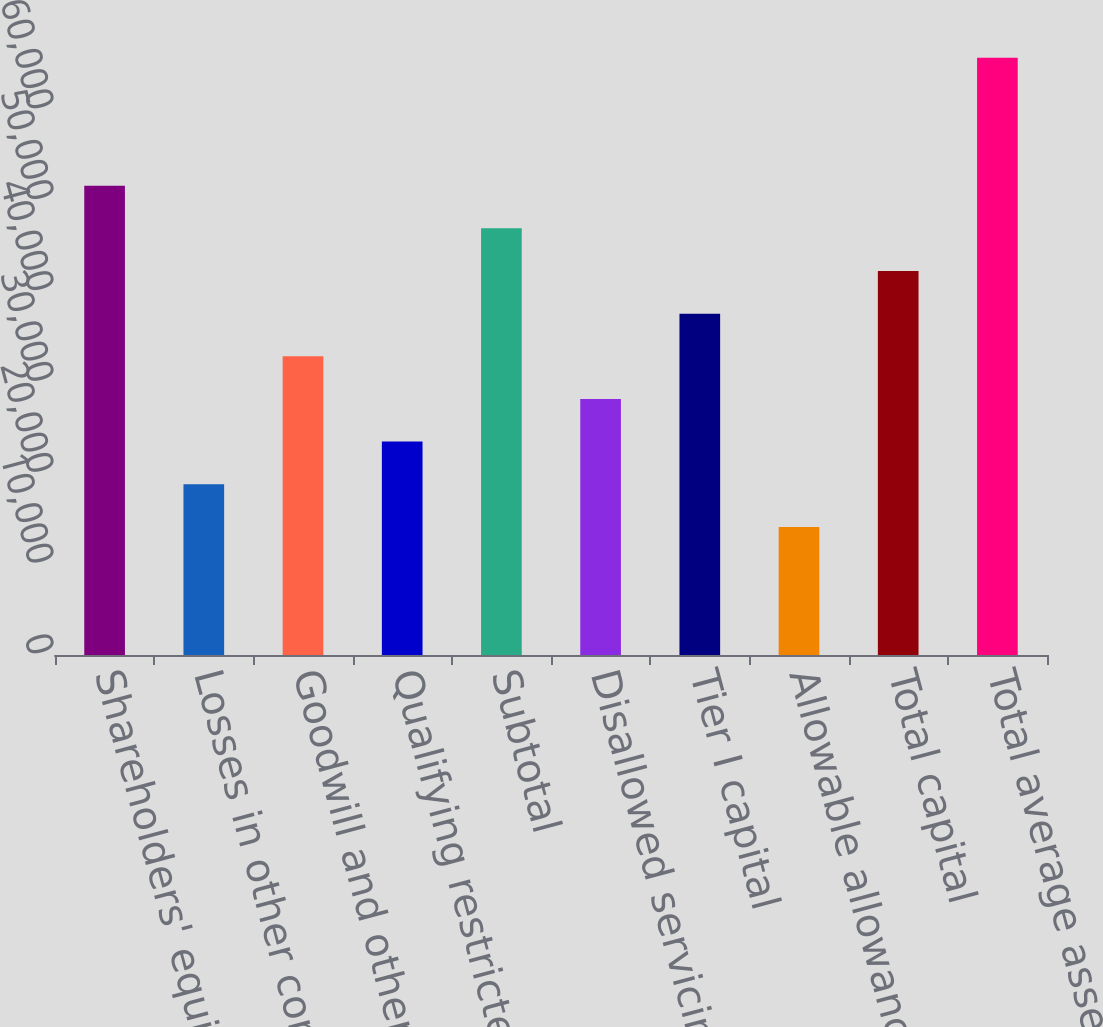Convert chart to OTSL. <chart><loc_0><loc_0><loc_500><loc_500><bar_chart><fcel>Shareholders' equity<fcel>Losses in other comprehensive<fcel>Goodwill and other intangible<fcel>Qualifying restricted core<fcel>Subtotal<fcel>Disallowed servicing assets<fcel>Tier I capital<fcel>Allowable allowance for loan<fcel>Total capital<fcel>Total average assets<nl><fcel>51660.1<fcel>18789.1<fcel>32876.7<fcel>23485<fcel>46964.2<fcel>28180.8<fcel>37572.5<fcel>14093.2<fcel>42268.3<fcel>65747.6<nl></chart> 